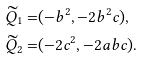<formula> <loc_0><loc_0><loc_500><loc_500>\widetilde { Q } _ { 1 } = & ( - b ^ { 2 } , - 2 b ^ { 2 } c ) , \\ \widetilde { Q } _ { 2 } = & ( - 2 c ^ { 2 } , - 2 a b c ) .</formula> 